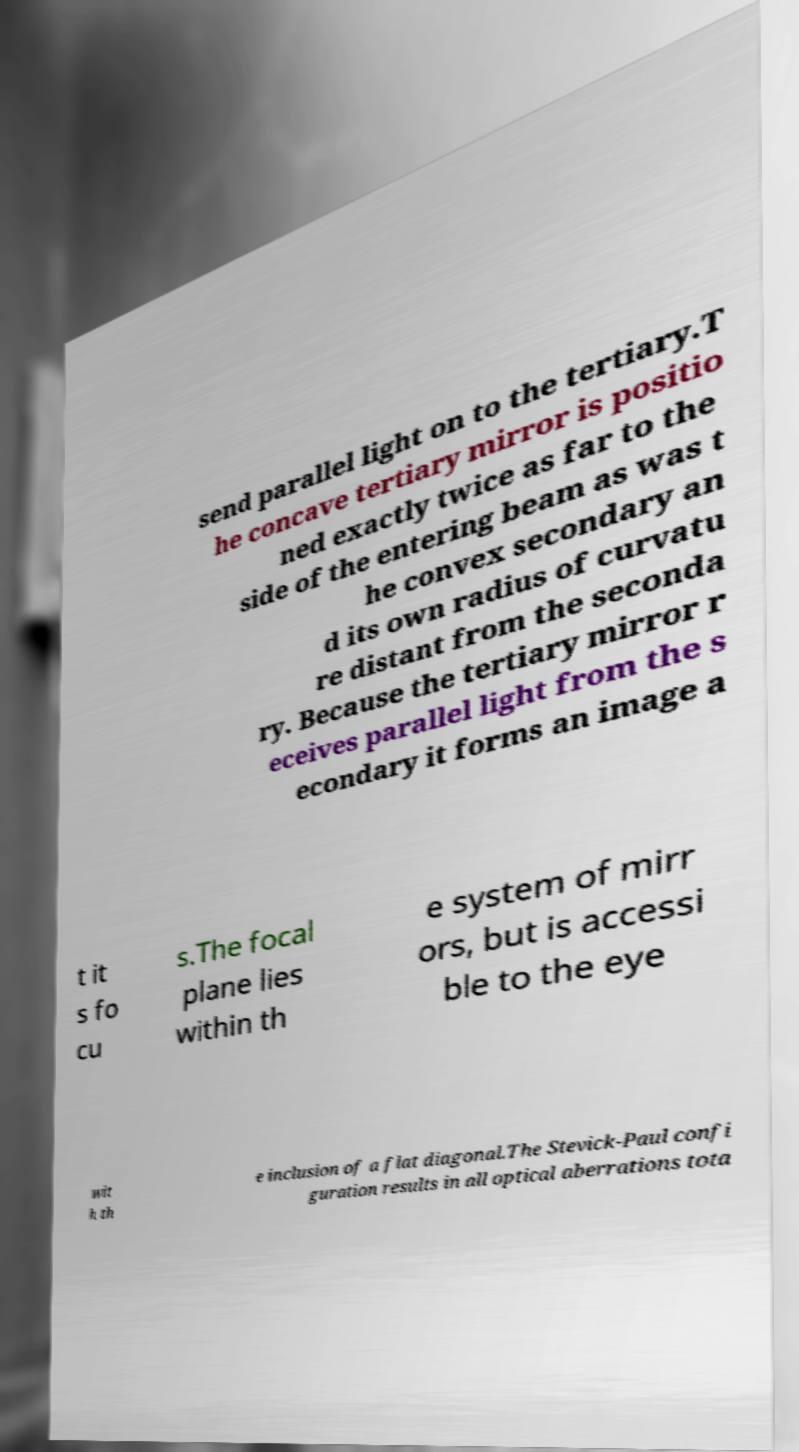What messages or text are displayed in this image? I need them in a readable, typed format. send parallel light on to the tertiary.T he concave tertiary mirror is positio ned exactly twice as far to the side of the entering beam as was t he convex secondary an d its own radius of curvatu re distant from the seconda ry. Because the tertiary mirror r eceives parallel light from the s econdary it forms an image a t it s fo cu s.The focal plane lies within th e system of mirr ors, but is accessi ble to the eye wit h th e inclusion of a flat diagonal.The Stevick-Paul confi guration results in all optical aberrations tota 